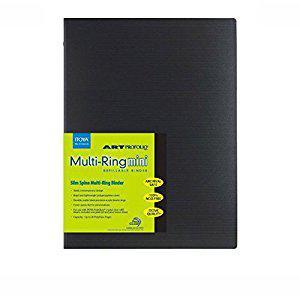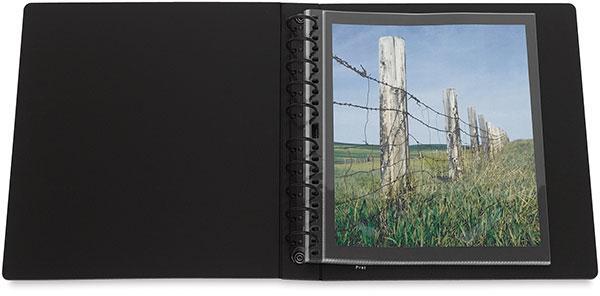The first image is the image on the left, the second image is the image on the right. Given the left and right images, does the statement "An image shows one closed black binder with a colored label on the front." hold true? Answer yes or no. Yes. The first image is the image on the left, the second image is the image on the right. Evaluate the accuracy of this statement regarding the images: "One photo features a single closed binder with a brand label on the front.". Is it true? Answer yes or no. Yes. 